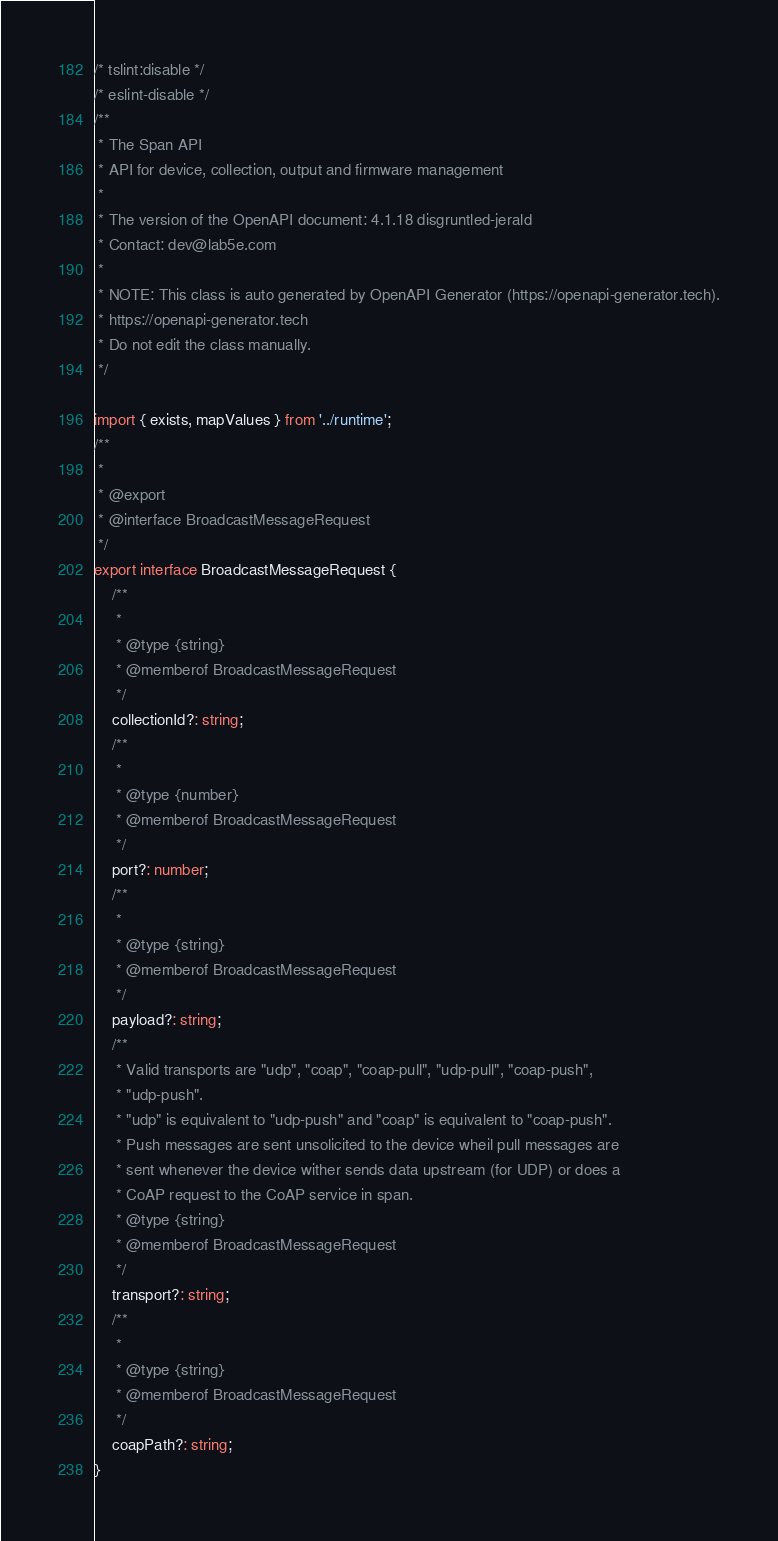Convert code to text. <code><loc_0><loc_0><loc_500><loc_500><_TypeScript_>/* tslint:disable */
/* eslint-disable */
/**
 * The Span API
 * API for device, collection, output and firmware management
 *
 * The version of the OpenAPI document: 4.1.18 disgruntled-jerald
 * Contact: dev@lab5e.com
 *
 * NOTE: This class is auto generated by OpenAPI Generator (https://openapi-generator.tech).
 * https://openapi-generator.tech
 * Do not edit the class manually.
 */

import { exists, mapValues } from '../runtime';
/**
 * 
 * @export
 * @interface BroadcastMessageRequest
 */
export interface BroadcastMessageRequest {
    /**
     * 
     * @type {string}
     * @memberof BroadcastMessageRequest
     */
    collectionId?: string;
    /**
     * 
     * @type {number}
     * @memberof BroadcastMessageRequest
     */
    port?: number;
    /**
     * 
     * @type {string}
     * @memberof BroadcastMessageRequest
     */
    payload?: string;
    /**
     * Valid transports are "udp", "coap", "coap-pull", "udp-pull", "coap-push",
     * "udp-push".
     * "udp" is equivalent to "udp-push" and "coap" is equivalent to "coap-push".
     * Push messages are sent unsolicited to the device wheil pull messages are
     * sent whenever the device wither sends data upstream (for UDP) or does a
     * CoAP request to the CoAP service in span.
     * @type {string}
     * @memberof BroadcastMessageRequest
     */
    transport?: string;
    /**
     * 
     * @type {string}
     * @memberof BroadcastMessageRequest
     */
    coapPath?: string;
}
</code> 